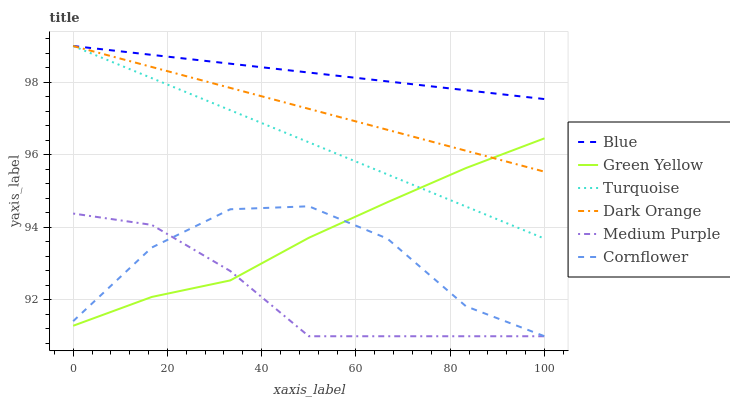Does Medium Purple have the minimum area under the curve?
Answer yes or no. Yes. Does Blue have the maximum area under the curve?
Answer yes or no. Yes. Does Dark Orange have the minimum area under the curve?
Answer yes or no. No. Does Dark Orange have the maximum area under the curve?
Answer yes or no. No. Is Blue the smoothest?
Answer yes or no. Yes. Is Cornflower the roughest?
Answer yes or no. Yes. Is Dark Orange the smoothest?
Answer yes or no. No. Is Dark Orange the roughest?
Answer yes or no. No. Does Cornflower have the lowest value?
Answer yes or no. Yes. Does Dark Orange have the lowest value?
Answer yes or no. No. Does Turquoise have the highest value?
Answer yes or no. Yes. Does Cornflower have the highest value?
Answer yes or no. No. Is Cornflower less than Blue?
Answer yes or no. Yes. Is Dark Orange greater than Medium Purple?
Answer yes or no. Yes. Does Medium Purple intersect Green Yellow?
Answer yes or no. Yes. Is Medium Purple less than Green Yellow?
Answer yes or no. No. Is Medium Purple greater than Green Yellow?
Answer yes or no. No. Does Cornflower intersect Blue?
Answer yes or no. No. 